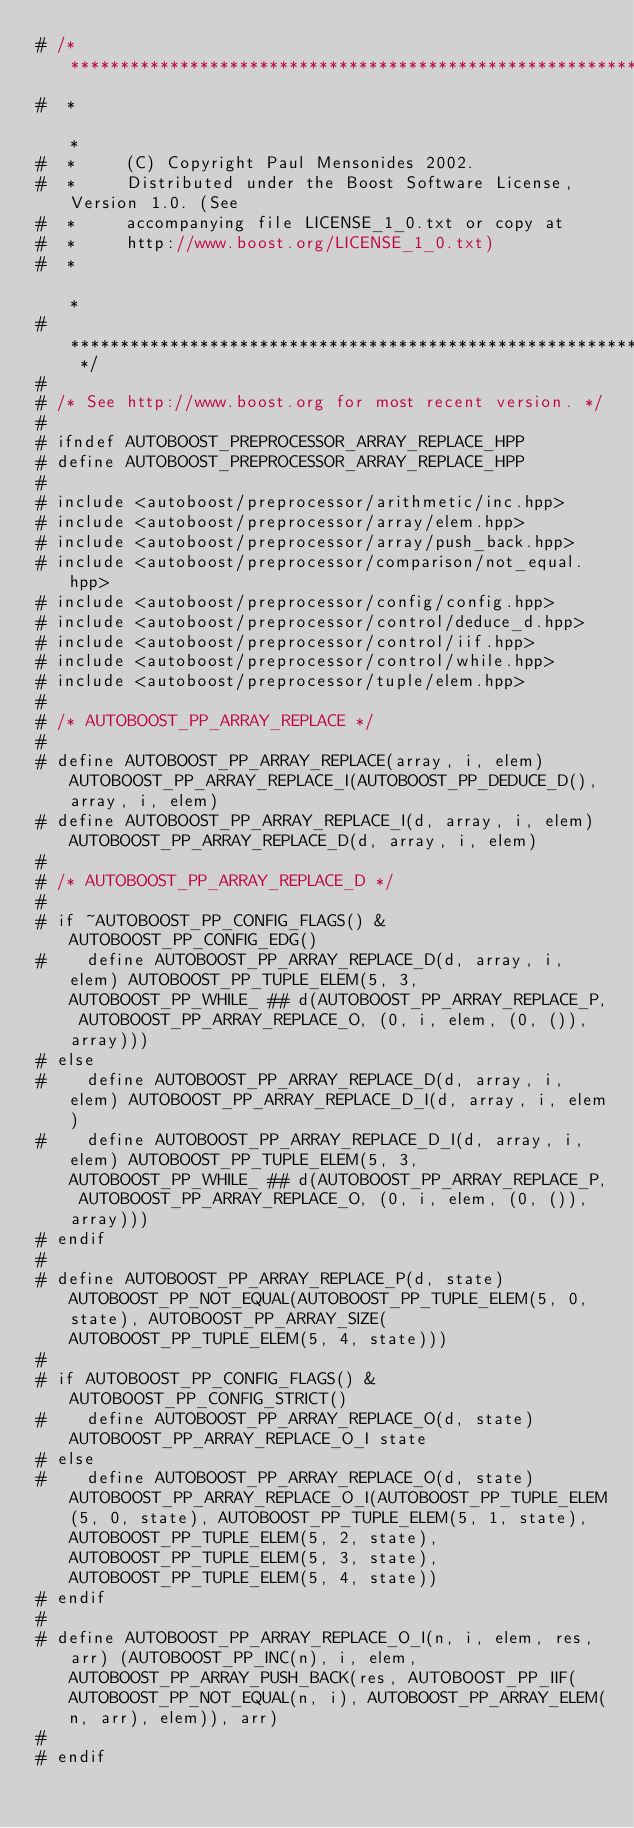Convert code to text. <code><loc_0><loc_0><loc_500><loc_500><_C++_># /* **************************************************************************
#  *                                                                          *
#  *     (C) Copyright Paul Mensonides 2002.
#  *     Distributed under the Boost Software License, Version 1.0. (See
#  *     accompanying file LICENSE_1_0.txt or copy at
#  *     http://www.boost.org/LICENSE_1_0.txt)
#  *                                                                          *
#  ************************************************************************** */
#
# /* See http://www.boost.org for most recent version. */
#
# ifndef AUTOBOOST_PREPROCESSOR_ARRAY_REPLACE_HPP
# define AUTOBOOST_PREPROCESSOR_ARRAY_REPLACE_HPP
#
# include <autoboost/preprocessor/arithmetic/inc.hpp>
# include <autoboost/preprocessor/array/elem.hpp>
# include <autoboost/preprocessor/array/push_back.hpp>
# include <autoboost/preprocessor/comparison/not_equal.hpp>
# include <autoboost/preprocessor/config/config.hpp>
# include <autoboost/preprocessor/control/deduce_d.hpp>
# include <autoboost/preprocessor/control/iif.hpp>
# include <autoboost/preprocessor/control/while.hpp>
# include <autoboost/preprocessor/tuple/elem.hpp>
#
# /* AUTOBOOST_PP_ARRAY_REPLACE */
#
# define AUTOBOOST_PP_ARRAY_REPLACE(array, i, elem) AUTOBOOST_PP_ARRAY_REPLACE_I(AUTOBOOST_PP_DEDUCE_D(), array, i, elem)
# define AUTOBOOST_PP_ARRAY_REPLACE_I(d, array, i, elem) AUTOBOOST_PP_ARRAY_REPLACE_D(d, array, i, elem)
#
# /* AUTOBOOST_PP_ARRAY_REPLACE_D */
#
# if ~AUTOBOOST_PP_CONFIG_FLAGS() & AUTOBOOST_PP_CONFIG_EDG()
#    define AUTOBOOST_PP_ARRAY_REPLACE_D(d, array, i, elem) AUTOBOOST_PP_TUPLE_ELEM(5, 3, AUTOBOOST_PP_WHILE_ ## d(AUTOBOOST_PP_ARRAY_REPLACE_P, AUTOBOOST_PP_ARRAY_REPLACE_O, (0, i, elem, (0, ()), array)))
# else
#    define AUTOBOOST_PP_ARRAY_REPLACE_D(d, array, i, elem) AUTOBOOST_PP_ARRAY_REPLACE_D_I(d, array, i, elem)
#    define AUTOBOOST_PP_ARRAY_REPLACE_D_I(d, array, i, elem) AUTOBOOST_PP_TUPLE_ELEM(5, 3, AUTOBOOST_PP_WHILE_ ## d(AUTOBOOST_PP_ARRAY_REPLACE_P, AUTOBOOST_PP_ARRAY_REPLACE_O, (0, i, elem, (0, ()), array)))
# endif
#
# define AUTOBOOST_PP_ARRAY_REPLACE_P(d, state) AUTOBOOST_PP_NOT_EQUAL(AUTOBOOST_PP_TUPLE_ELEM(5, 0, state), AUTOBOOST_PP_ARRAY_SIZE(AUTOBOOST_PP_TUPLE_ELEM(5, 4, state)))
#
# if AUTOBOOST_PP_CONFIG_FLAGS() & AUTOBOOST_PP_CONFIG_STRICT()
#    define AUTOBOOST_PP_ARRAY_REPLACE_O(d, state) AUTOBOOST_PP_ARRAY_REPLACE_O_I state
# else
#    define AUTOBOOST_PP_ARRAY_REPLACE_O(d, state) AUTOBOOST_PP_ARRAY_REPLACE_O_I(AUTOBOOST_PP_TUPLE_ELEM(5, 0, state), AUTOBOOST_PP_TUPLE_ELEM(5, 1, state), AUTOBOOST_PP_TUPLE_ELEM(5, 2, state), AUTOBOOST_PP_TUPLE_ELEM(5, 3, state), AUTOBOOST_PP_TUPLE_ELEM(5, 4, state))
# endif
#
# define AUTOBOOST_PP_ARRAY_REPLACE_O_I(n, i, elem, res, arr) (AUTOBOOST_PP_INC(n), i, elem, AUTOBOOST_PP_ARRAY_PUSH_BACK(res, AUTOBOOST_PP_IIF(AUTOBOOST_PP_NOT_EQUAL(n, i), AUTOBOOST_PP_ARRAY_ELEM(n, arr), elem)), arr)
#
# endif
</code> 